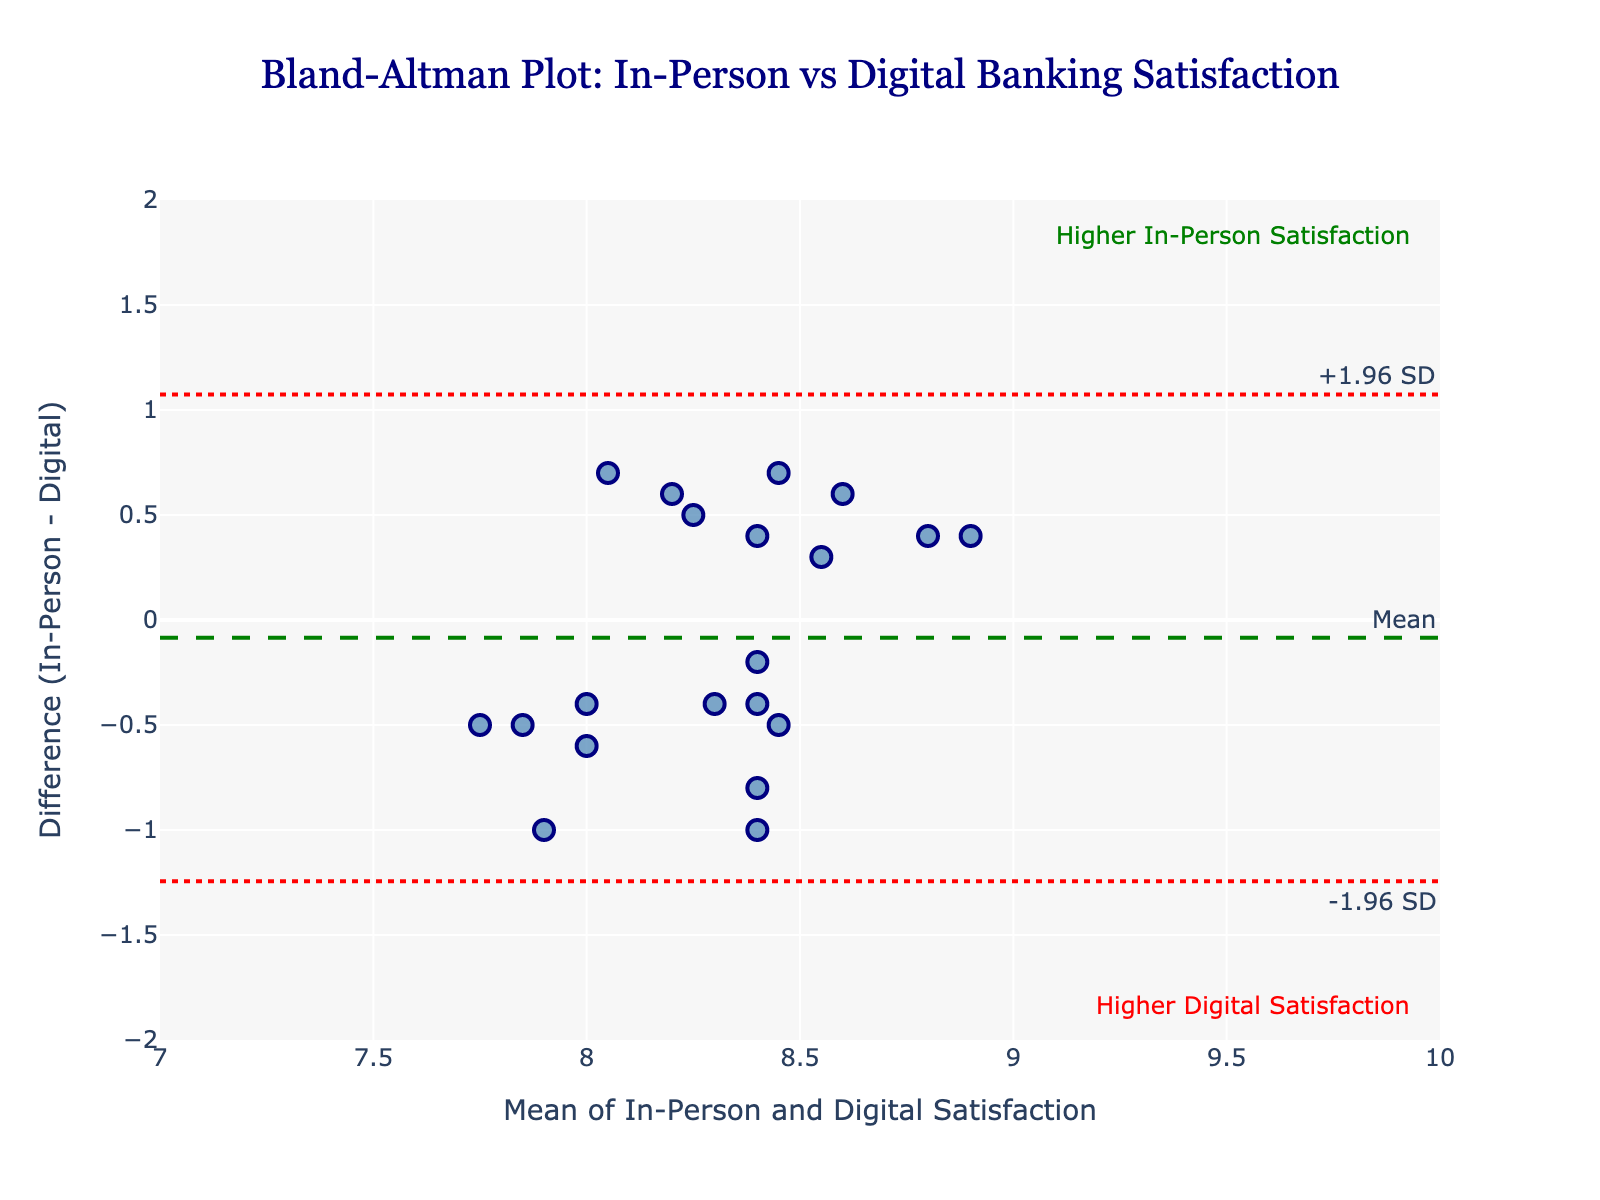What is the title of the figure? The title is usually displayed at the top of the figure. It gives an overview of what the figure is about.
Answer: Bland-Altman Plot: In-Person vs Digital Banking Satisfaction How many data points are shown in the plot? Count each scattered point visible in the plot.
Answer: 19 What do the horizontal green and red lines represent? Check the labels and colors next to the lines for their meanings: the green line represents the mean difference, while the red lines represent the limits of agreement.
Answer: Mean difference, ±1.96 SD What is the average difference between in-person and digital satisfaction ratings? Look at the green dashed line labeled "Mean" for the value of the average difference.
Answer: about 0.05 Which customer had the highest mean satisfaction rating between in-person and digital banking services? Find the point with the highest x-coordinate on the plot, as the x-axis represents the mean of in-person and digital satisfaction.
Answer: Elizabeth White Which customer had the largest negative difference between in-person and digital satisfaction ratings? Look at the data points below the green dashed line and identify the point furthest down, indicating the largest negative difference.
Answer: Patricia Harris What do the red dotted lines signify and what are their values? Look at the red dotted lines above and below the green dashed line. They signify the limits of agreement (Mean ± 1.96 SD) and their values are labeled next to them.
Answer: Mean ±1.96 SD, about -0.81 and 0.91 Which satisfaction method had the overall higher rating, in-person or digital? If most points are above the green dashed line, in-person is higher on average; if below, digital is higher on average.
Answer: In-Person How many customers rated digital satisfaction higher than in-person satisfaction? Count the data points below the green dashed line. These points indicate customers who rated digital satisfaction higher.
Answer: 9 What is the range of the mean satisfaction ratings on the x-axis? Look at the values on the x-axis, which range from the lowest to the highest mean satisfaction rating.
Answer: 7.45 to 8.85 